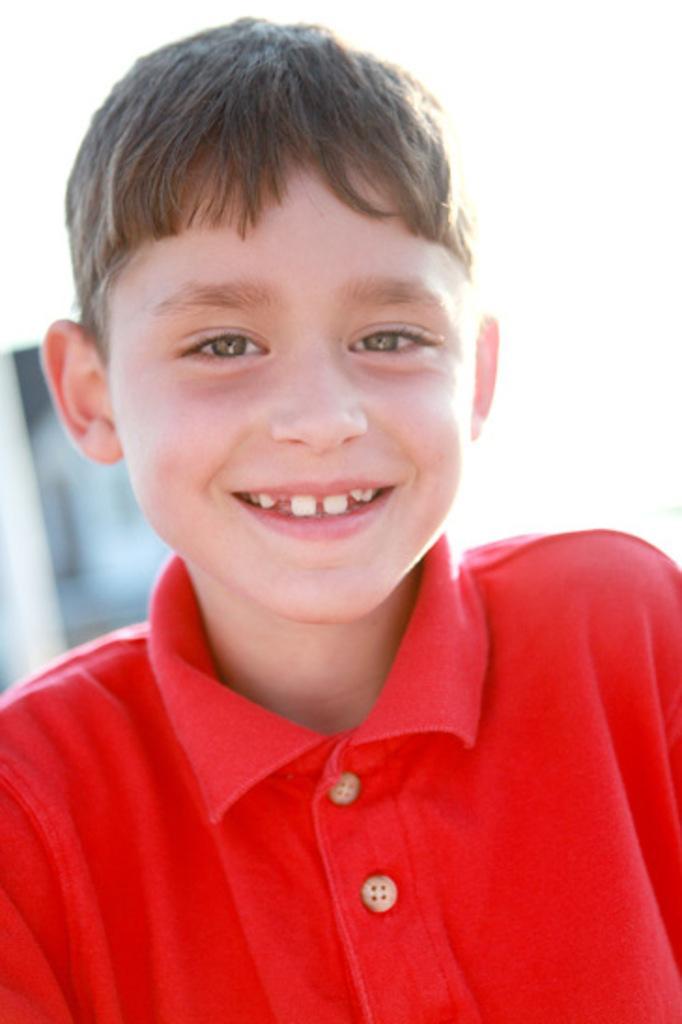Please provide a concise description of this image. In this image we can see a boy wearing t-shirt. 